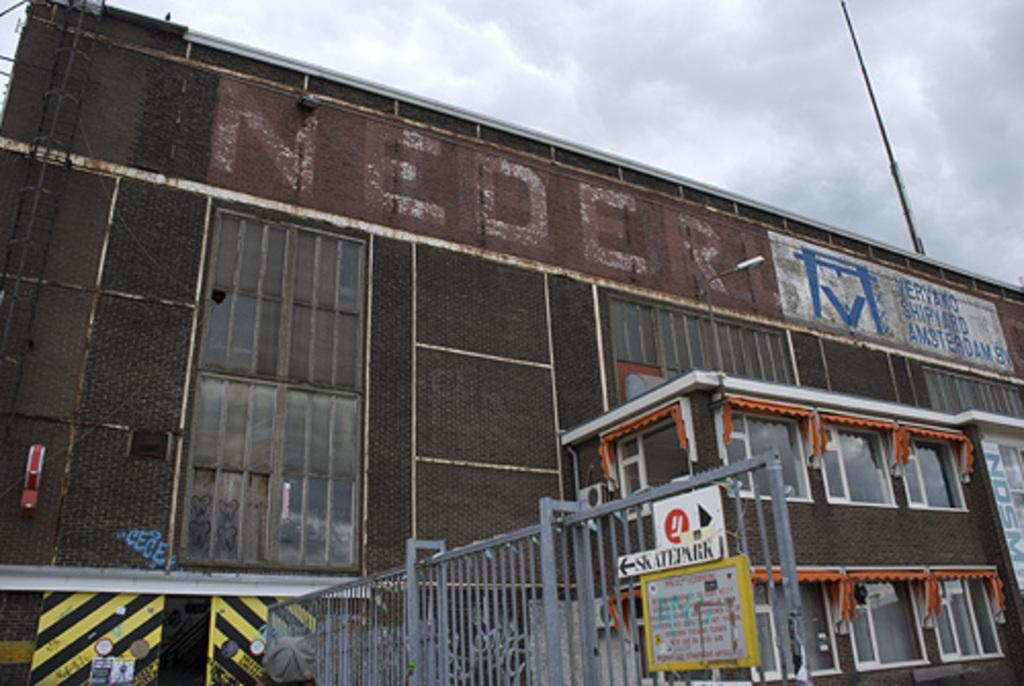What type of structure is visible in the picture? There is a building in the picture. What is located near the building? There is an iron fence in the picture. What is the condition of the sky in the picture? The sky is clear in the picture. How many boats can be seen sailing through the window in the picture? There is no window or boats present in the image. What shape is the iron fence in the picture? The provided facts do not mention the shape of the iron fence, so it cannot be determined from the image. 